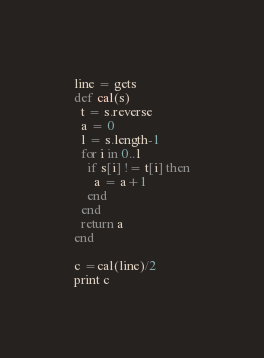<code> <loc_0><loc_0><loc_500><loc_500><_Ruby_>line = gets
def cal(s)
  t = s.reverse
  a = 0
  l = s.length-1
  for i in 0..l
    if s[i] != t[i] then
      a = a+1
    end
  end
  return a
end
  
c =cal(line)/2
print c</code> 